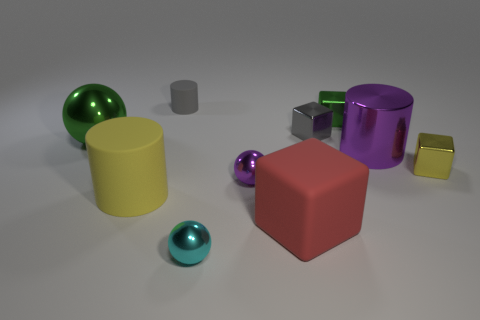Subtract 1 blocks. How many blocks are left? 3 Subtract all cyan blocks. Subtract all brown balls. How many blocks are left? 4 Subtract all cubes. How many objects are left? 6 Subtract 1 cyan spheres. How many objects are left? 9 Subtract all small red metallic balls. Subtract all cyan metal objects. How many objects are left? 9 Add 1 small yellow metallic objects. How many small yellow metallic objects are left? 2 Add 9 cyan spheres. How many cyan spheres exist? 10 